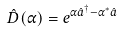Convert formula to latex. <formula><loc_0><loc_0><loc_500><loc_500>\hat { D } ( \alpha ) = e ^ { \alpha \hat { a } ^ { \dagger } - \alpha ^ { * } \hat { a } }</formula> 